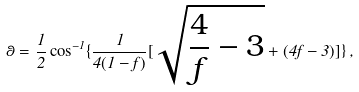<formula> <loc_0><loc_0><loc_500><loc_500>\theta = \frac { 1 } { 2 } \cos ^ { - 1 } \{ \frac { 1 } { 4 ( 1 - f ) } [ \sqrt { \frac { 4 } { f } - 3 } + ( 4 f - 3 ) ] \} \, ,</formula> 